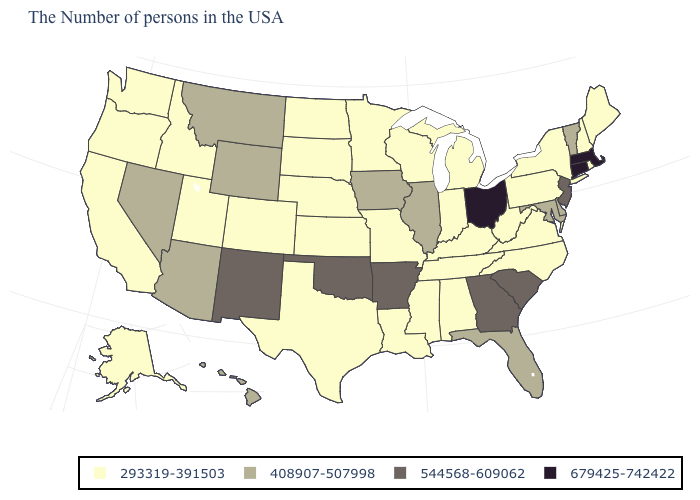Does the map have missing data?
Quick response, please. No. What is the highest value in the USA?
Quick response, please. 679425-742422. What is the value of New York?
Be succinct. 293319-391503. What is the value of Ohio?
Answer briefly. 679425-742422. Name the states that have a value in the range 293319-391503?
Quick response, please. Maine, Rhode Island, New Hampshire, New York, Pennsylvania, Virginia, North Carolina, West Virginia, Michigan, Kentucky, Indiana, Alabama, Tennessee, Wisconsin, Mississippi, Louisiana, Missouri, Minnesota, Kansas, Nebraska, Texas, South Dakota, North Dakota, Colorado, Utah, Idaho, California, Washington, Oregon, Alaska. Name the states that have a value in the range 679425-742422?
Give a very brief answer. Massachusetts, Connecticut, Ohio. What is the value of Iowa?
Be succinct. 408907-507998. Does Washington have the lowest value in the West?
Give a very brief answer. Yes. Does Massachusetts have the highest value in the USA?
Keep it brief. Yes. Which states have the lowest value in the USA?
Short answer required. Maine, Rhode Island, New Hampshire, New York, Pennsylvania, Virginia, North Carolina, West Virginia, Michigan, Kentucky, Indiana, Alabama, Tennessee, Wisconsin, Mississippi, Louisiana, Missouri, Minnesota, Kansas, Nebraska, Texas, South Dakota, North Dakota, Colorado, Utah, Idaho, California, Washington, Oregon, Alaska. Name the states that have a value in the range 544568-609062?
Quick response, please. New Jersey, South Carolina, Georgia, Arkansas, Oklahoma, New Mexico. Among the states that border Oregon , which have the lowest value?
Write a very short answer. Idaho, California, Washington. Does Massachusetts have the highest value in the USA?
Write a very short answer. Yes. What is the value of New York?
Keep it brief. 293319-391503. How many symbols are there in the legend?
Write a very short answer. 4. 